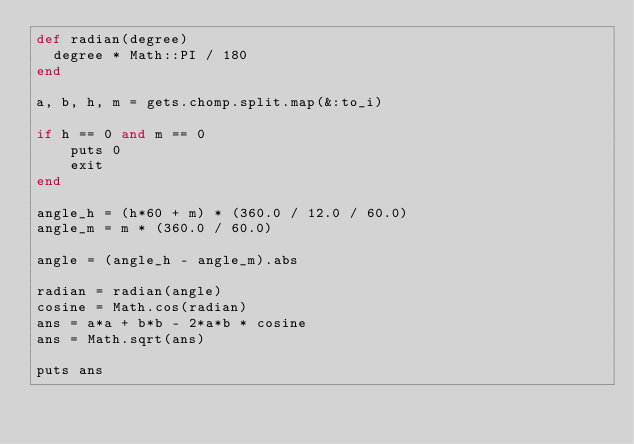Convert code to text. <code><loc_0><loc_0><loc_500><loc_500><_Ruby_>def radian(degree)
  degree * Math::PI / 180
end

a, b, h, m = gets.chomp.split.map(&:to_i)

if h == 0 and m == 0
	puts 0
	exit
end
  
angle_h = (h*60 + m) * (360.0 / 12.0 / 60.0)
angle_m = m * (360.0 / 60.0)

angle = (angle_h - angle_m).abs

radian = radian(angle)
cosine = Math.cos(radian)
ans = a*a + b*b - 2*a*b * cosine
ans = Math.sqrt(ans)

puts ans
</code> 